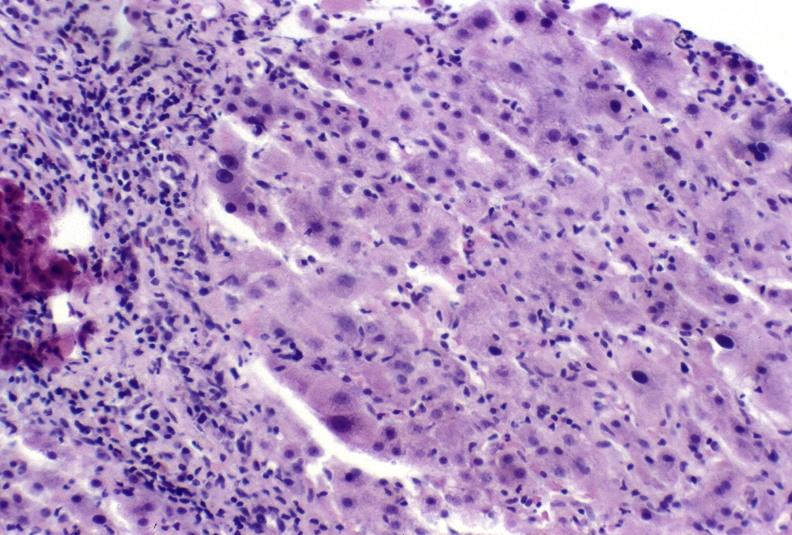what is present?
Answer the question using a single word or phrase. Liver 